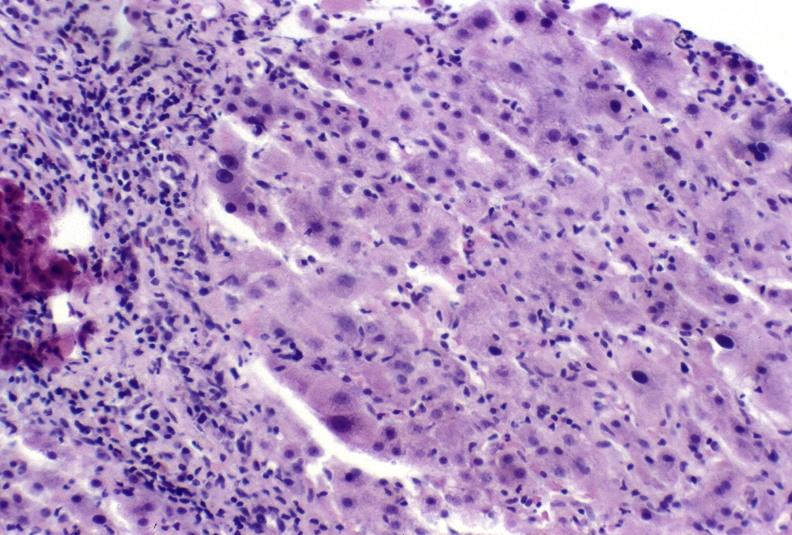what is present?
Answer the question using a single word or phrase. Liver 